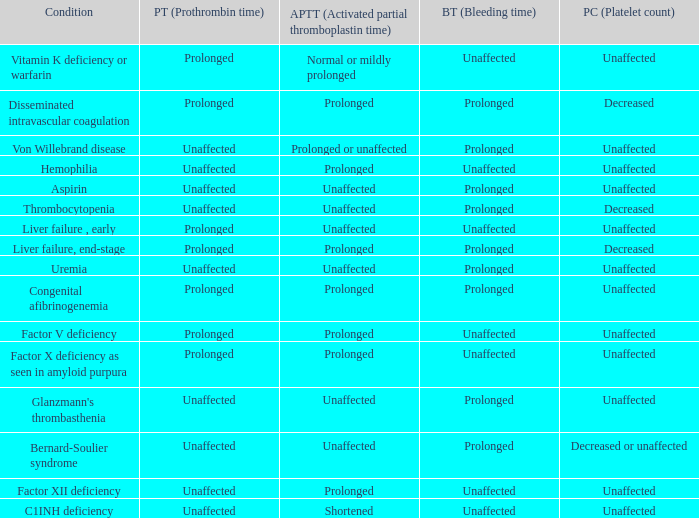Which Bleeding has a Condition of congenital afibrinogenemia? Prolonged. 